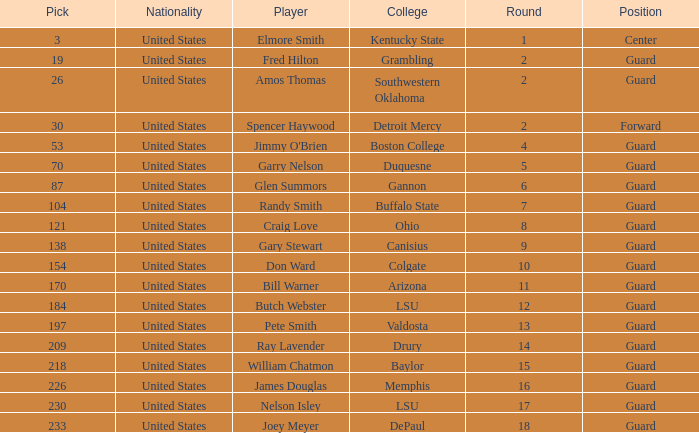WHAT COLLEGE HAS A ROUND LARGER THAN 9, WITH BUTCH WEBSTER? LSU. 